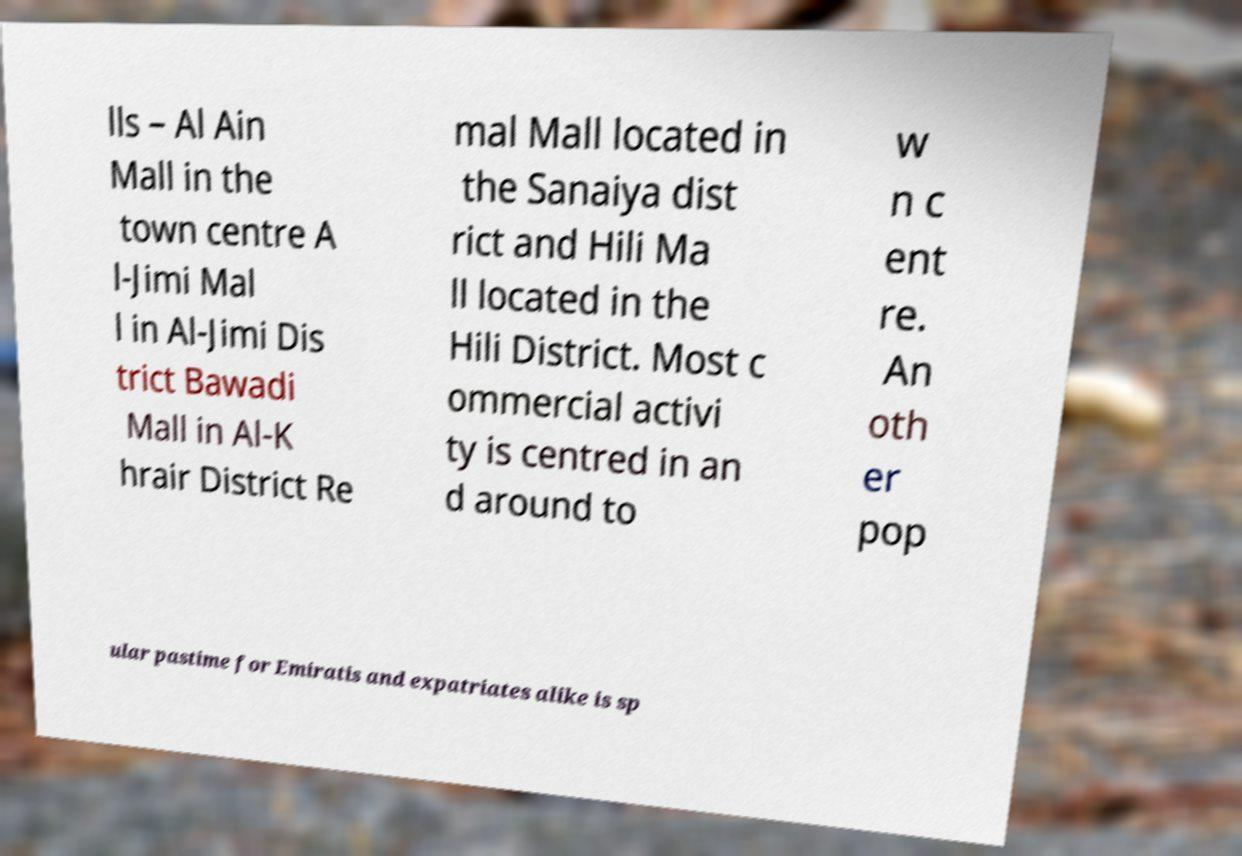For documentation purposes, I need the text within this image transcribed. Could you provide that? lls – Al Ain Mall in the town centre A l-Jimi Mal l in Al-Jimi Dis trict Bawadi Mall in Al-K hrair District Re mal Mall located in the Sanaiya dist rict and Hili Ma ll located in the Hili District. Most c ommercial activi ty is centred in an d around to w n c ent re. An oth er pop ular pastime for Emiratis and expatriates alike is sp 